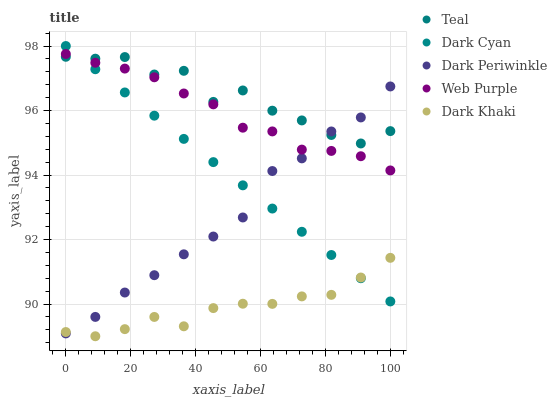Does Dark Khaki have the minimum area under the curve?
Answer yes or no. Yes. Does Teal have the maximum area under the curve?
Answer yes or no. Yes. Does Web Purple have the minimum area under the curve?
Answer yes or no. No. Does Web Purple have the maximum area under the curve?
Answer yes or no. No. Is Dark Cyan the smoothest?
Answer yes or no. Yes. Is Teal the roughest?
Answer yes or no. Yes. Is Dark Khaki the smoothest?
Answer yes or no. No. Is Dark Khaki the roughest?
Answer yes or no. No. Does Dark Khaki have the lowest value?
Answer yes or no. Yes. Does Web Purple have the lowest value?
Answer yes or no. No. Does Dark Cyan have the highest value?
Answer yes or no. Yes. Does Web Purple have the highest value?
Answer yes or no. No. Is Dark Khaki less than Teal?
Answer yes or no. Yes. Is Web Purple greater than Dark Khaki?
Answer yes or no. Yes. Does Web Purple intersect Teal?
Answer yes or no. Yes. Is Web Purple less than Teal?
Answer yes or no. No. Is Web Purple greater than Teal?
Answer yes or no. No. Does Dark Khaki intersect Teal?
Answer yes or no. No. 